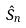Convert formula to latex. <formula><loc_0><loc_0><loc_500><loc_500>\hat { S } _ { n }</formula> 